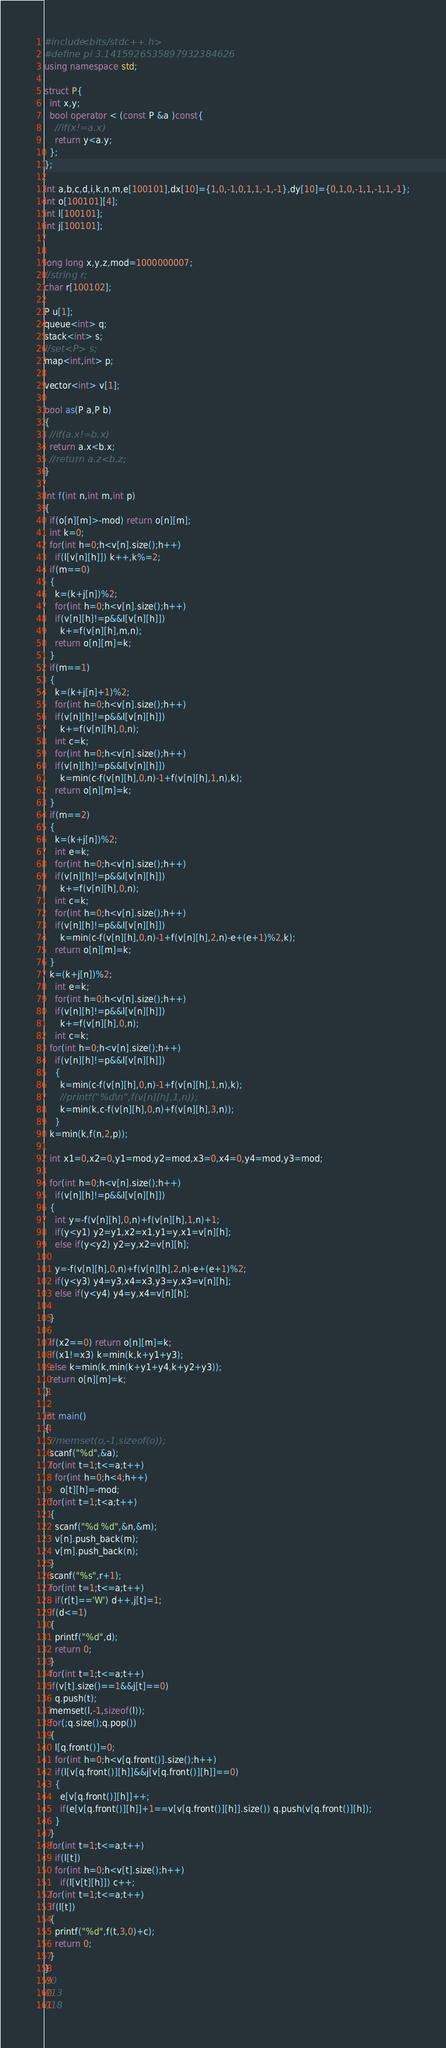<code> <loc_0><loc_0><loc_500><loc_500><_C++_>#include<bits/stdc++.h>
#define pi 3.1415926535897932384626
using namespace std;
      
struct P{
  int x,y;
  bool operator < (const P &a )const{
    //if(x!=a.x)
    return y<a.y;
  };
};

int a,b,c,d,i,k,n,m,e[100101],dx[10]={1,0,-1,0,1,1,-1,-1},dy[10]={0,1,0,-1,1,-1,1,-1};
int o[100101][4];
int l[100101];
int j[100101];


long long x,y,z,mod=1000000007;
//string r;
char r[100102];

P u[1];
queue<int> q;
stack<int> s;
//set<P> s;
map<int,int> p;

vector<int> v[1];

bool as(P a,P b)
{
  //if(a.x!=b.x)
  return a.x<b.x;
  //return a.z<b.z;
}

int f(int n,int m,int p)
{
  if(o[n][m]>-mod) return o[n][m];
  int k=0;
  for(int h=0;h<v[n].size();h++)
    if(l[v[n][h]]) k++,k%=2;
  if(m==0)
  {
    k=(k+j[n])%2;
    for(int h=0;h<v[n].size();h++)
    if(v[n][h]!=p&&l[v[n][h]])
      k+=f(v[n][h],m,n);
    return o[n][m]=k;
  }
  if(m==1)
  {
    k=(k+j[n]+1)%2;
    for(int h=0;h<v[n].size();h++)
    if(v[n][h]!=p&&l[v[n][h]])
      k+=f(v[n][h],0,n);
    int c=k;
    for(int h=0;h<v[n].size();h++)
    if(v[n][h]!=p&&l[v[n][h]])
      k=min(c-f(v[n][h],0,n)-1+f(v[n][h],1,n),k);
    return o[n][m]=k;
  }
  if(m==2)
  {
    k=(k+j[n])%2;
    int e=k;
    for(int h=0;h<v[n].size();h++)
    if(v[n][h]!=p&&l[v[n][h]])
      k+=f(v[n][h],0,n);
    int c=k;
    for(int h=0;h<v[n].size();h++)
    if(v[n][h]!=p&&l[v[n][h]])
      k=min(c-f(v[n][h],0,n)-1+f(v[n][h],2,n)-e+(e+1)%2,k);
    return o[n][m]=k;
  }
  k=(k+j[n])%2;
    int e=k;
    for(int h=0;h<v[n].size();h++)
    if(v[n][h]!=p&&l[v[n][h]])
      k+=f(v[n][h],0,n);
    int c=k;
  for(int h=0;h<v[n].size();h++)
    if(v[n][h]!=p&&l[v[n][h]])
    {
      k=min(c-f(v[n][h],0,n)-1+f(v[n][h],1,n),k);
      //printf("%d\n",f(v[n][h],1,n));
      k=min(k,c-f(v[n][h],0,n)+f(v[n][h],3,n));
    }
  k=min(k,f(n,2,p));
  
  int x1=0,x2=0,y1=mod,y2=mod,x3=0,x4=0,y4=mod,y3=mod;
  
  for(int h=0;h<v[n].size();h++)
    if(v[n][h]!=p&&l[v[n][h]])
  {
    int y=-f(v[n][h],0,n)+f(v[n][h],1,n)+1;
    if(y<y1) y2=y1,x2=x1,y1=y,x1=v[n][h];
    else if(y<y2) y2=y,x2=v[n][h];
    
    y=-f(v[n][h],0,n)+f(v[n][h],2,n)-e+(e+1)%2;
    if(y<y3) y4=y3,x4=x3,y3=y,x3=v[n][h];
    else if(y<y4) y4=y,x4=v[n][h];
    
  }
  
  if(x2==0) return o[n][m]=k;
  if(x1!=x3) k=min(k,k+y1+y3);
  else k=min(k,min(k+y1+y4,k+y2+y3));
  return o[n][m]=k;
}

int main()
{
  //memset(o,-1,sizeof(o));
  scanf("%d",&a);
  for(int t=1;t<=a;t++)
    for(int h=0;h<4;h++)
      o[t][h]=-mod;
  for(int t=1;t<a;t++)
  {
    scanf("%d %d",&n,&m);
    v[n].push_back(m);
    v[m].push_back(n);
  }
  scanf("%s",r+1);
  for(int t=1;t<=a;t++)
    if(r[t]=='W') d++,j[t]=1;
  if(d<=1)
  {
    printf("%d",d);
    return 0;
  }
  for(int t=1;t<=a;t++)
  if(v[t].size()==1&&j[t]==0)
    q.push(t);
  memset(l,-1,sizeof(l));
  for(;q.size();q.pop())
  {
    l[q.front()]=0;
    for(int h=0;h<v[q.front()].size();h++)
    if(l[v[q.front()][h]]&&j[v[q.front()][h]]==0)
    {
      e[v[q.front()][h]]++;
      if(e[v[q.front()][h]]+1==v[v[q.front()][h]].size()) q.push(v[q.front()][h]);
    }
  }
  for(int t=1;t<=a;t++)
    if(l[t])
    for(int h=0;h<v[t].size();h++)
      if(l[v[t][h]]) c++;
  for(int t=1;t<=a;t++)
  if(l[t])
  {
    printf("%d",f(t,3,0)+c);
    return 0;
  }
}
//0
//13
//18

</code> 